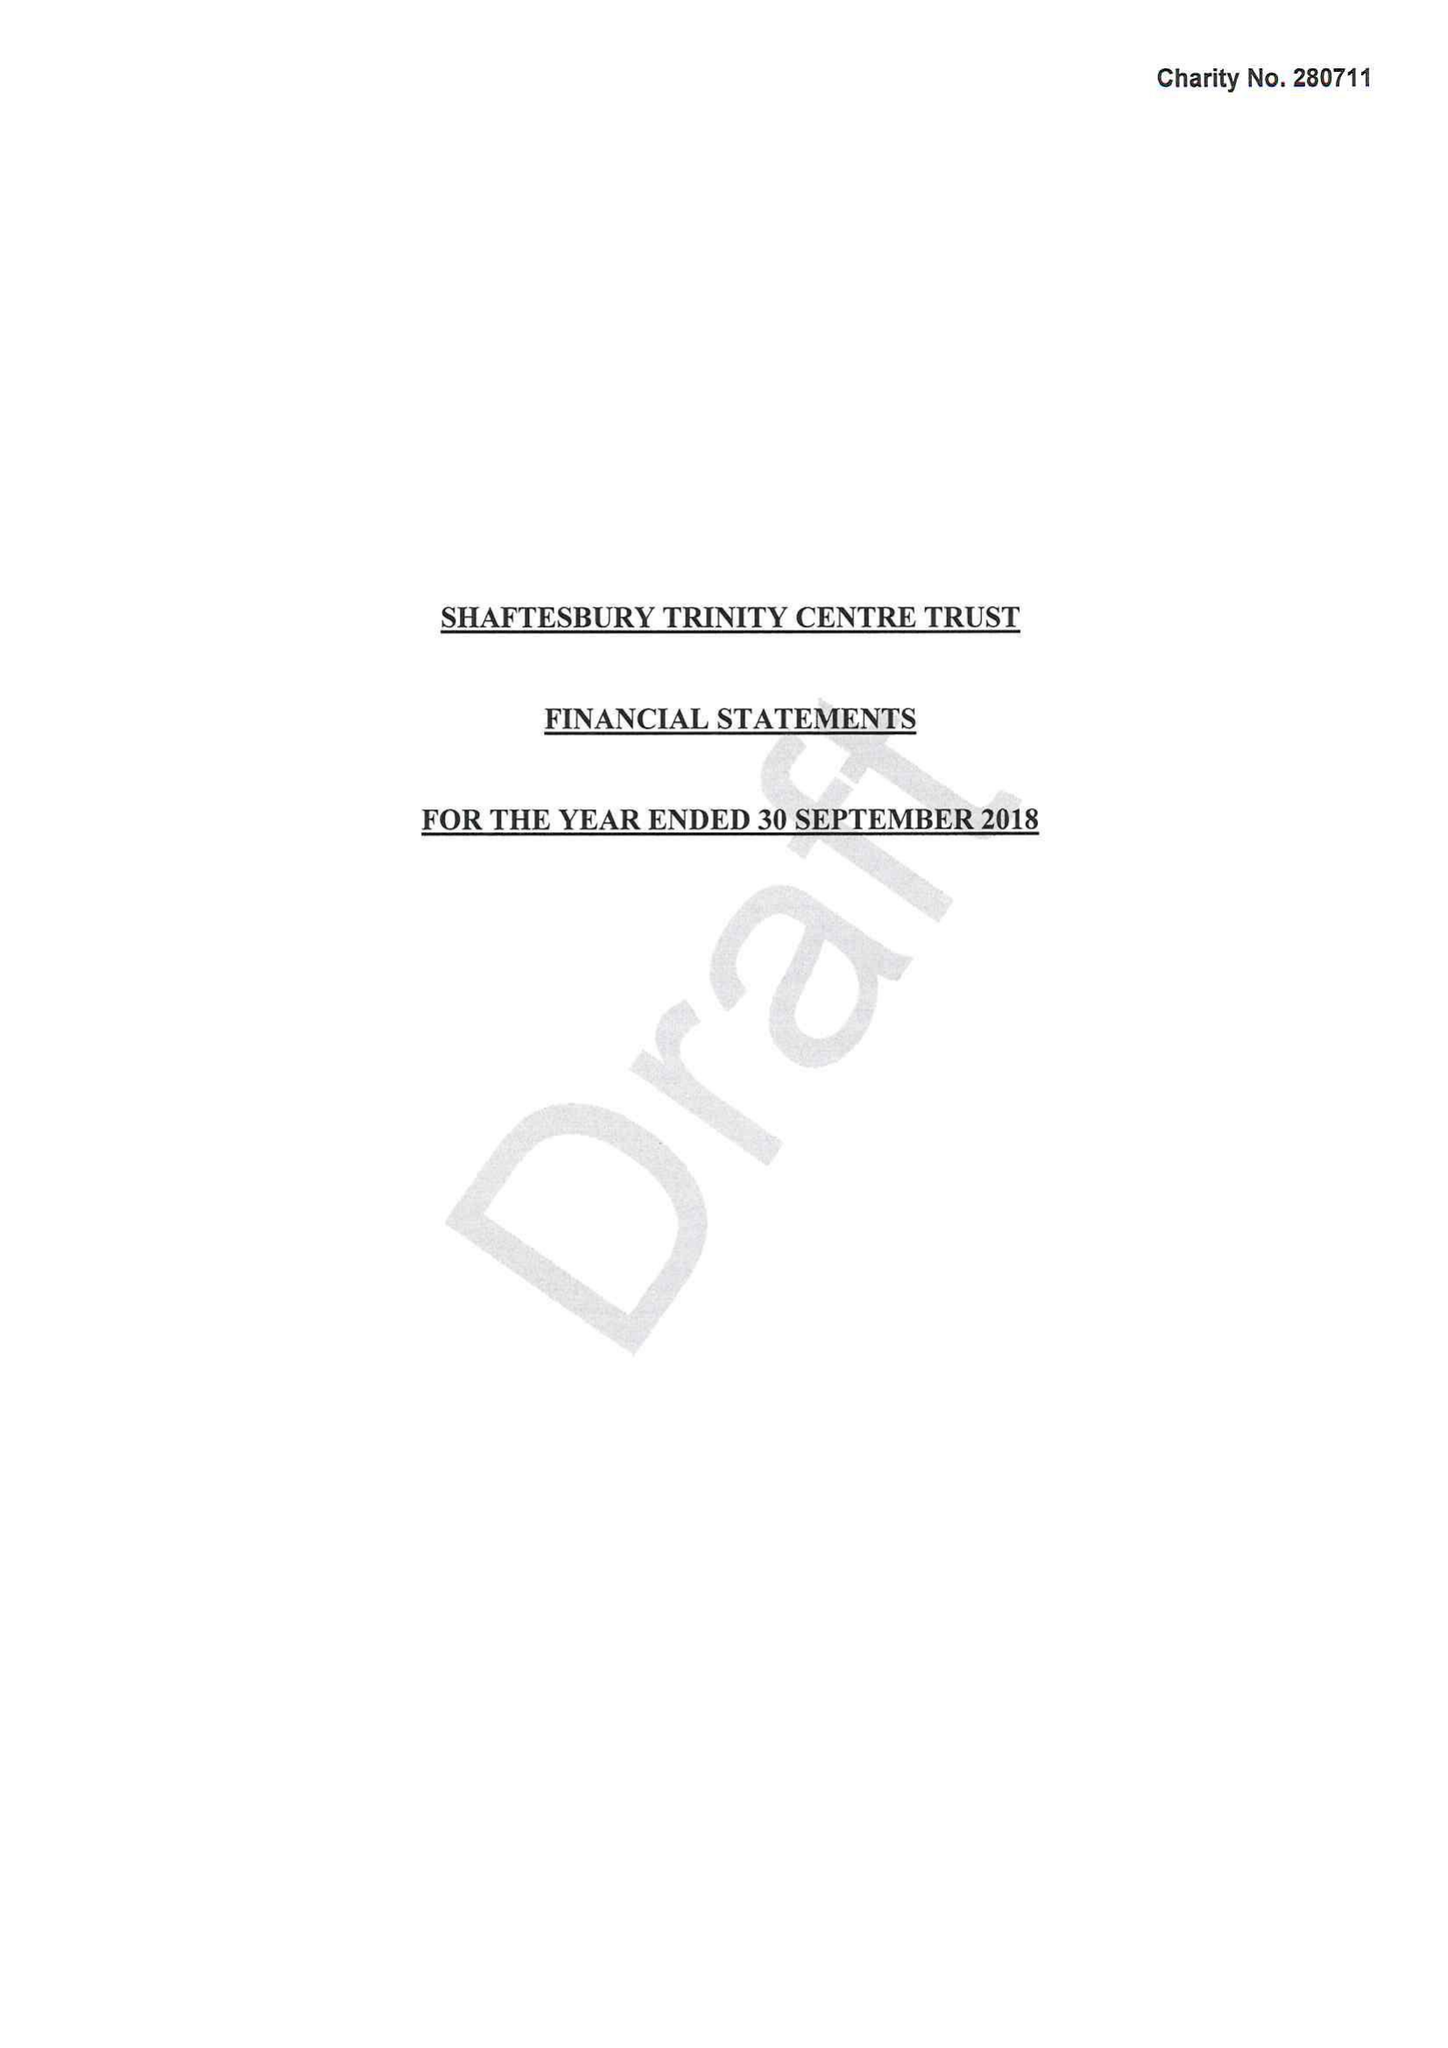What is the value for the charity_name?
Answer the question using a single word or phrase. Shaftesbury Trinity Centre Trust 